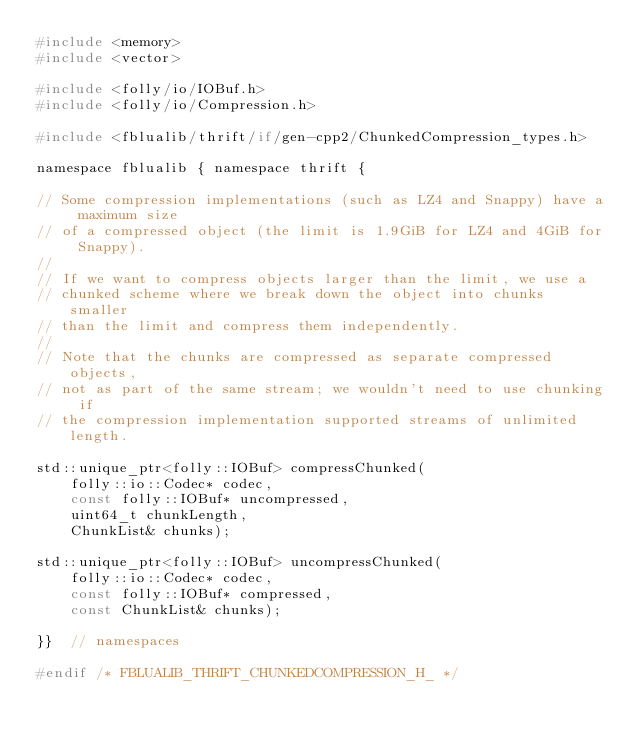<code> <loc_0><loc_0><loc_500><loc_500><_C_>#include <memory>
#include <vector>

#include <folly/io/IOBuf.h>
#include <folly/io/Compression.h>

#include <fblualib/thrift/if/gen-cpp2/ChunkedCompression_types.h>

namespace fblualib { namespace thrift {

// Some compression implementations (such as LZ4 and Snappy) have a maximum size
// of a compressed object (the limit is 1.9GiB for LZ4 and 4GiB for Snappy).
//
// If we want to compress objects larger than the limit, we use a
// chunked scheme where we break down the object into chunks smaller
// than the limit and compress them independently.
//
// Note that the chunks are compressed as separate compressed objects,
// not as part of the same stream; we wouldn't need to use chunking if
// the compression implementation supported streams of unlimited length.

std::unique_ptr<folly::IOBuf> compressChunked(
    folly::io::Codec* codec,
    const folly::IOBuf* uncompressed,
    uint64_t chunkLength,
    ChunkList& chunks);

std::unique_ptr<folly::IOBuf> uncompressChunked(
    folly::io::Codec* codec,
    const folly::IOBuf* compressed,
    const ChunkList& chunks);

}}  // namespaces

#endif /* FBLUALIB_THRIFT_CHUNKEDCOMPRESSION_H_ */
</code> 